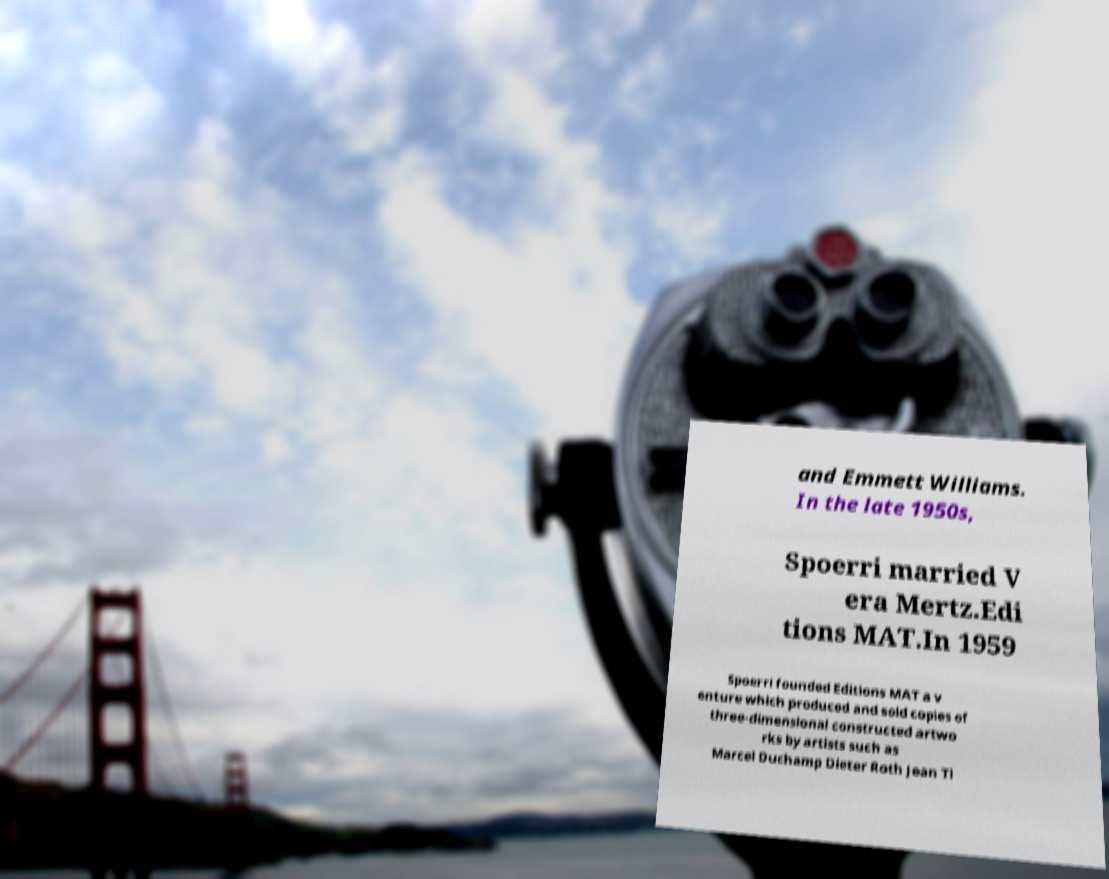Could you assist in decoding the text presented in this image and type it out clearly? and Emmett Williams. In the late 1950s, Spoerri married V era Mertz.Edi tions MAT.In 1959 Spoerri founded Editions MAT a v enture which produced and sold copies of three-dimensional constructed artwo rks by artists such as Marcel Duchamp Dieter Roth Jean Ti 